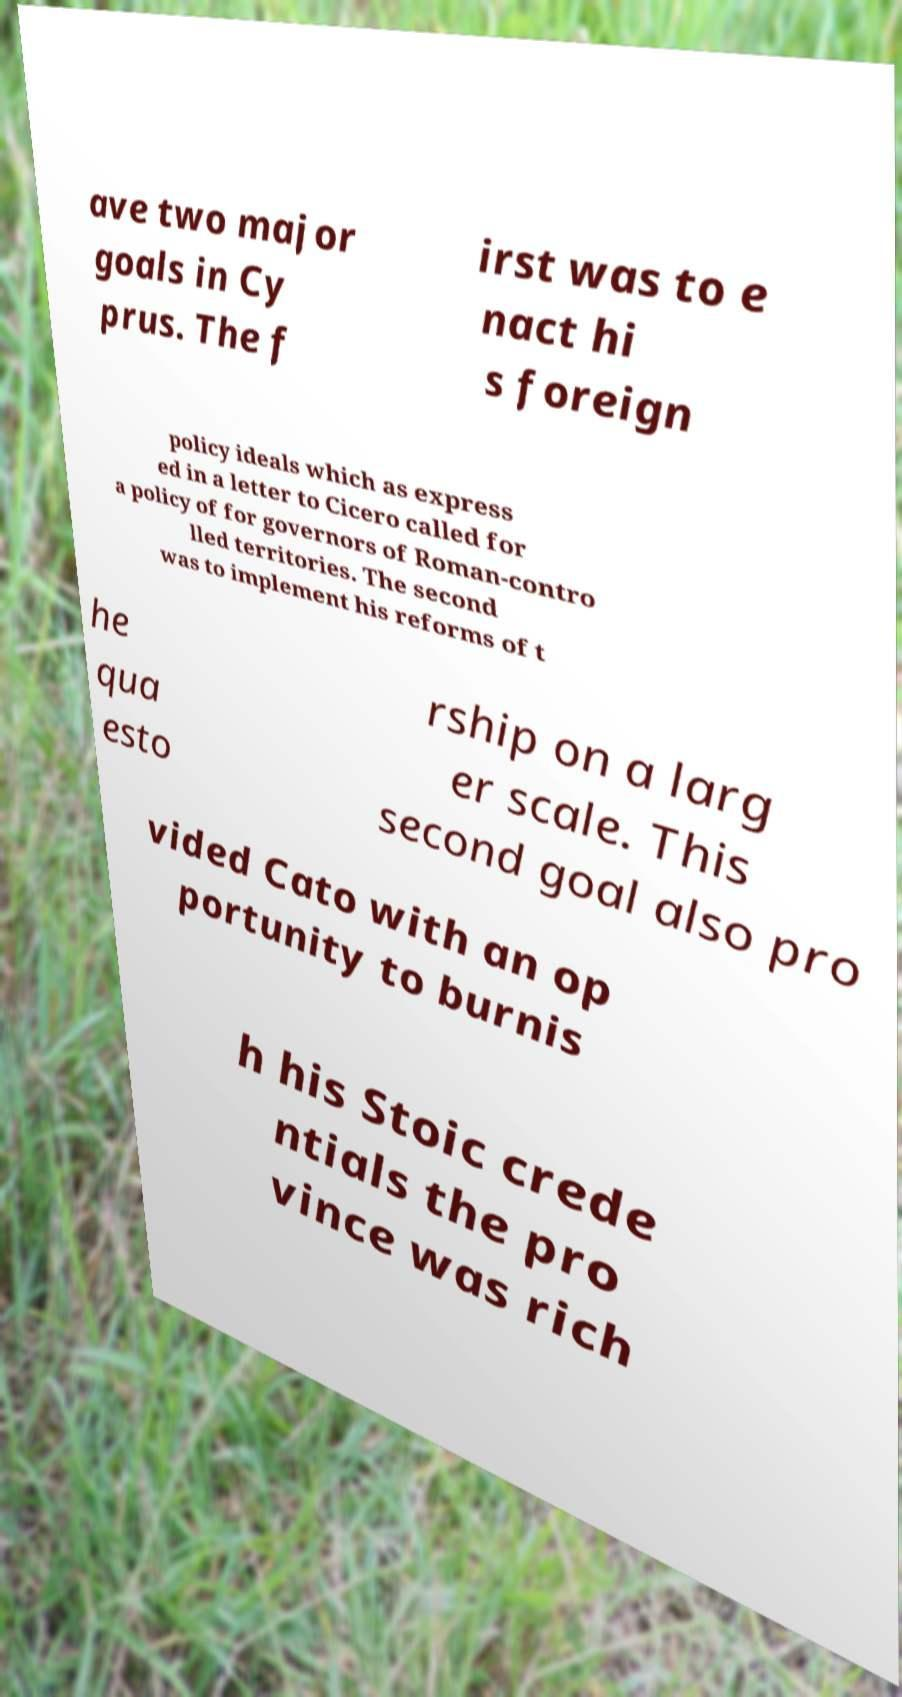Can you accurately transcribe the text from the provided image for me? ave two major goals in Cy prus. The f irst was to e nact hi s foreign policy ideals which as express ed in a letter to Cicero called for a policy of for governors of Roman-contro lled territories. The second was to implement his reforms of t he qua esto rship on a larg er scale. This second goal also pro vided Cato with an op portunity to burnis h his Stoic crede ntials the pro vince was rich 